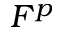Convert formula to latex. <formula><loc_0><loc_0><loc_500><loc_500>F ^ { p }</formula> 